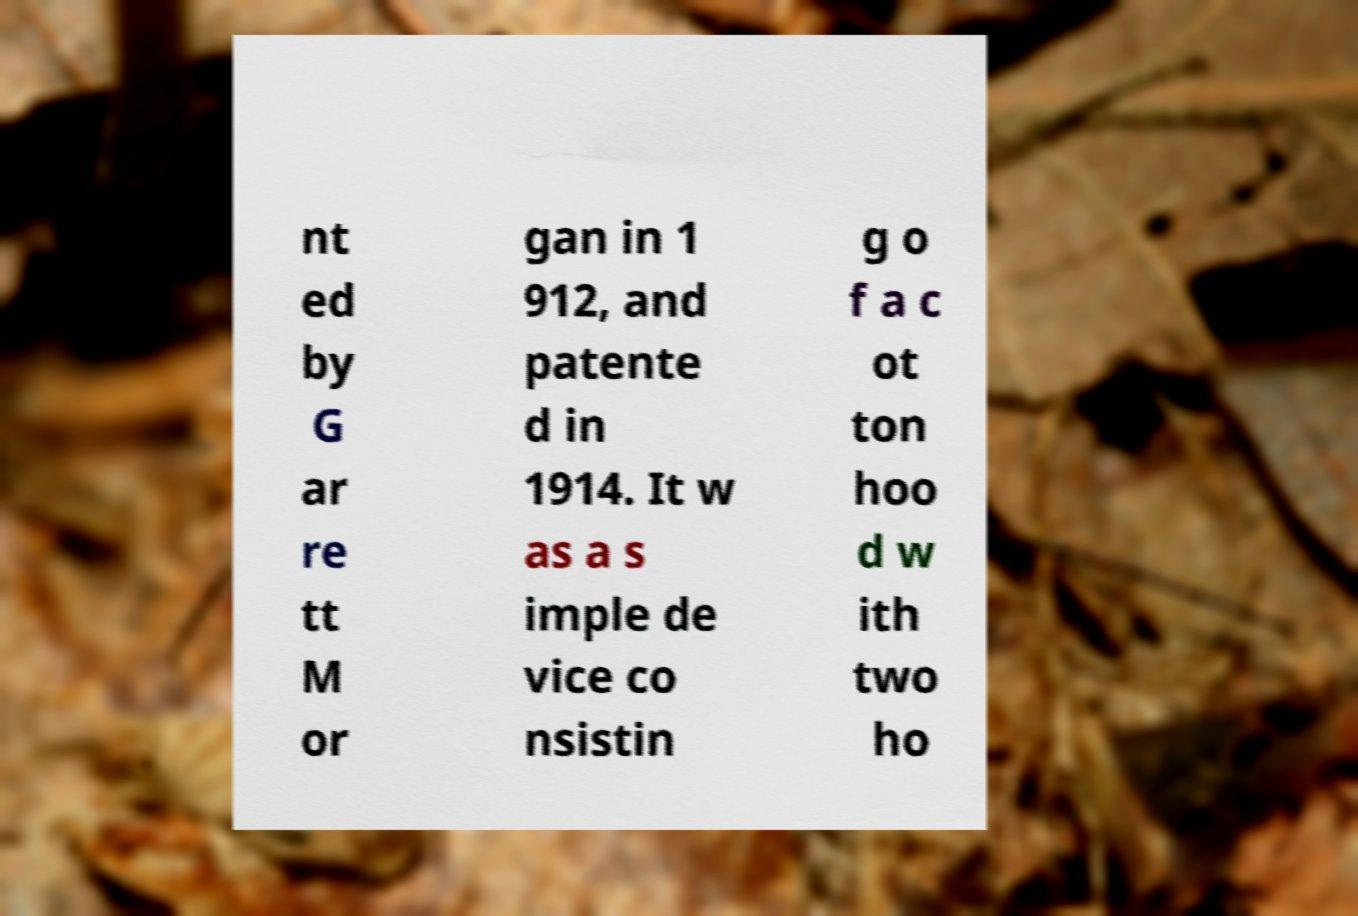Please read and relay the text visible in this image. What does it say? nt ed by G ar re tt M or gan in 1 912, and patente d in 1914. It w as a s imple de vice co nsistin g o f a c ot ton hoo d w ith two ho 